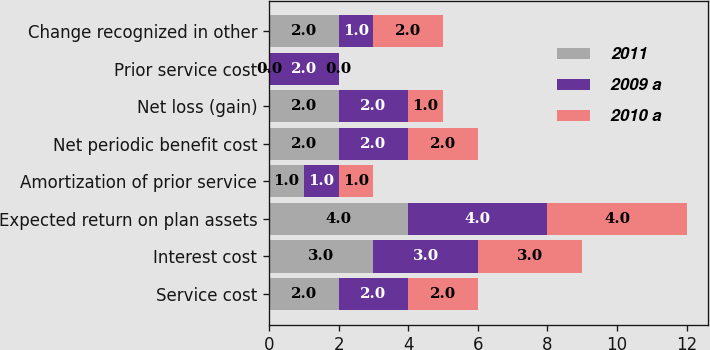Convert chart to OTSL. <chart><loc_0><loc_0><loc_500><loc_500><stacked_bar_chart><ecel><fcel>Service cost<fcel>Interest cost<fcel>Expected return on plan assets<fcel>Amortization of prior service<fcel>Net periodic benefit cost<fcel>Net loss (gain)<fcel>Prior service cost<fcel>Change recognized in other<nl><fcel>2011<fcel>2<fcel>3<fcel>4<fcel>1<fcel>2<fcel>2<fcel>0<fcel>2<nl><fcel>2009 a<fcel>2<fcel>3<fcel>4<fcel>1<fcel>2<fcel>2<fcel>2<fcel>1<nl><fcel>2010 a<fcel>2<fcel>3<fcel>4<fcel>1<fcel>2<fcel>1<fcel>0<fcel>2<nl></chart> 